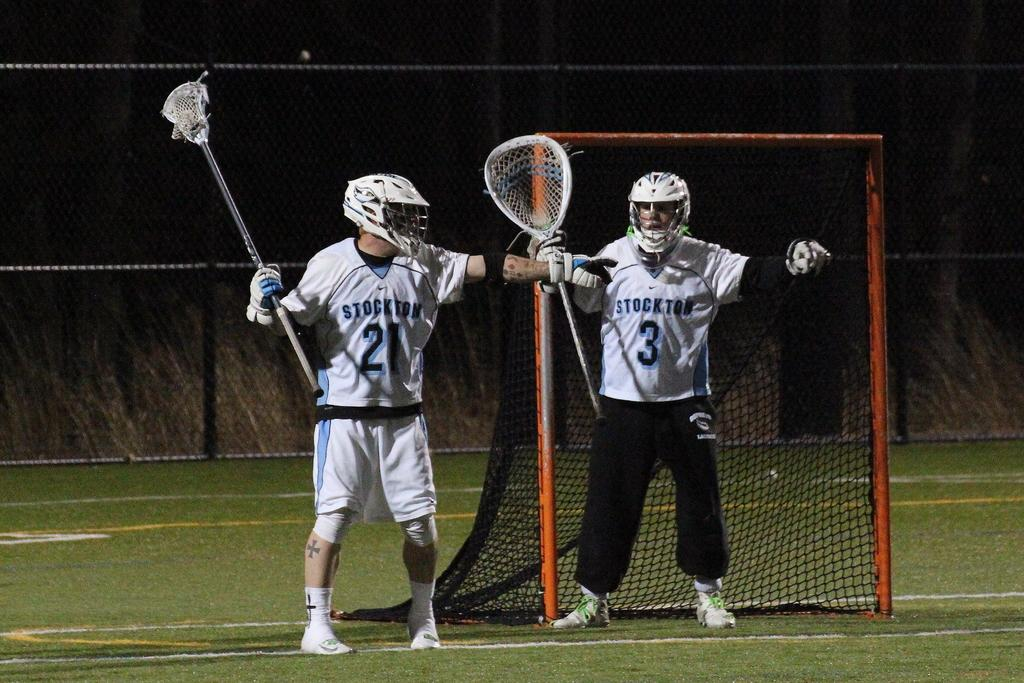How many people are in the image? There are two people standing in the image. What are the people wearing? The people are wearing clothes, gloves, helmets, and shoes. What are the people holding in their hands? The people are holding an object in their hands. What can be seen in the background of the image? There is a glass, a fence, and a goal court in the image. What industry is depicted in the image? There is no specific industry depicted in the image; it features two people wearing protective gear and holding an object. How does the glass drop in the image? The glass does not drop in the image; it is stationary and visible in the background. 